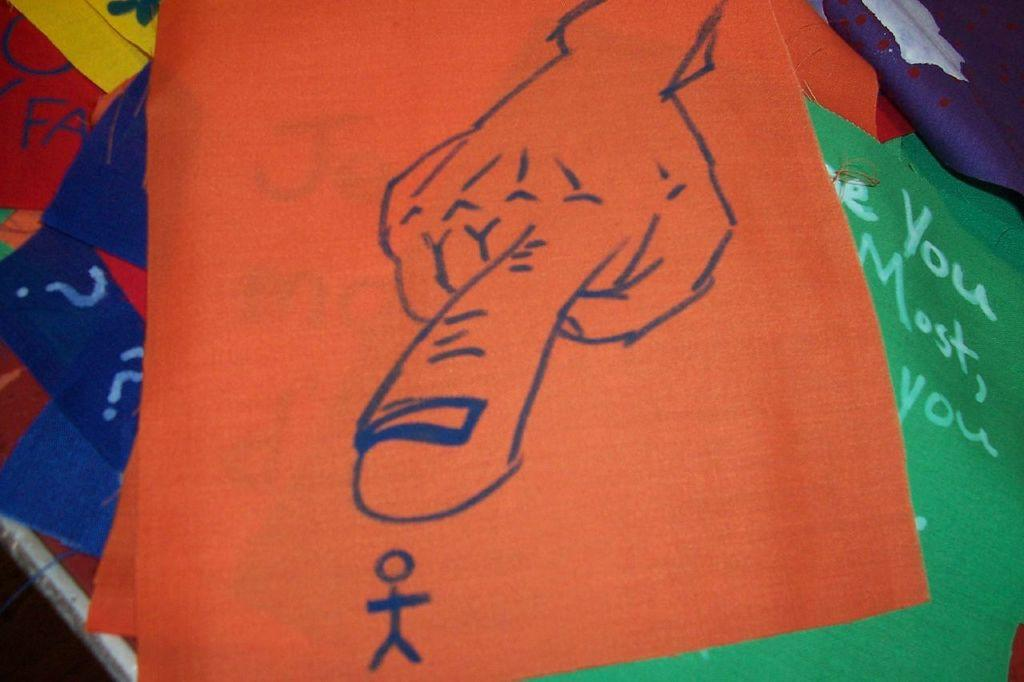What type of items can be seen in the image? There are clothes of different colors in the image. What features do the clothes have? The clothes have designs and text. What type of reaction can be seen when the clothes are exposed to a spark? There is no spark present in the image, and therefore no reaction can be observed. 